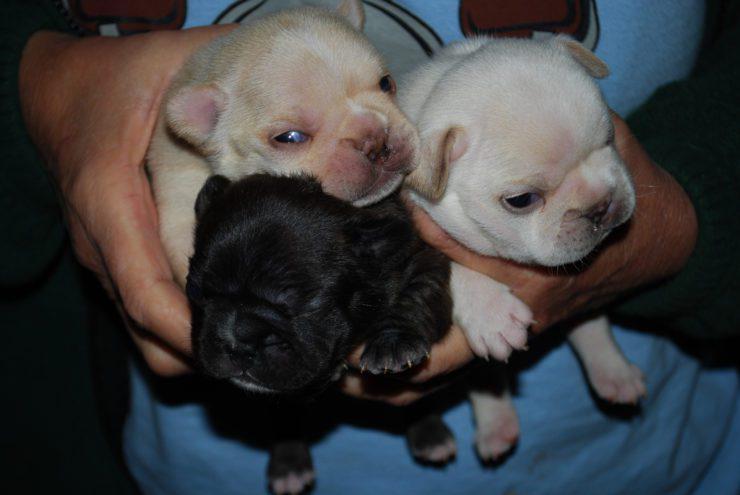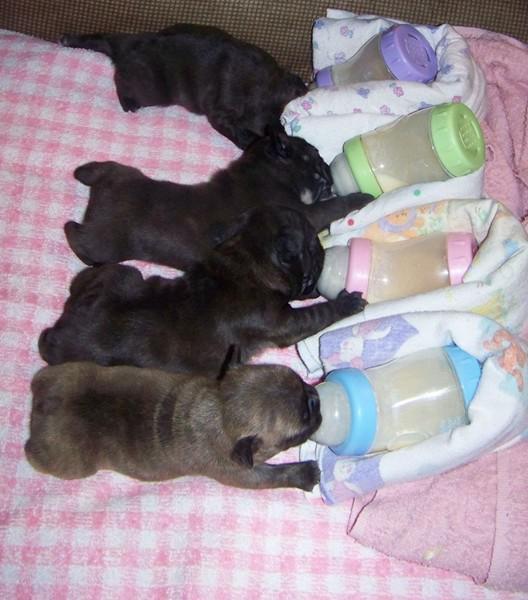The first image is the image on the left, the second image is the image on the right. Evaluate the accuracy of this statement regarding the images: "A mother dog is laying on her side feeding at least 3 puppies.". Is it true? Answer yes or no. No. The first image is the image on the left, the second image is the image on the right. For the images shown, is this caption "The right image contains an adult dog nursing her puppies." true? Answer yes or no. No. 